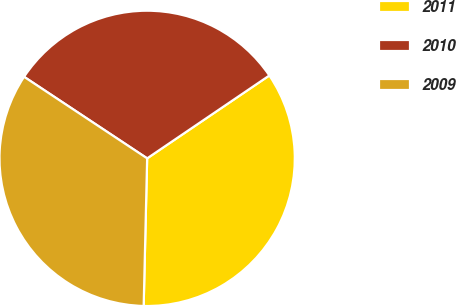Convert chart. <chart><loc_0><loc_0><loc_500><loc_500><pie_chart><fcel>2011<fcel>2010<fcel>2009<nl><fcel>34.86%<fcel>31.2%<fcel>33.94%<nl></chart> 